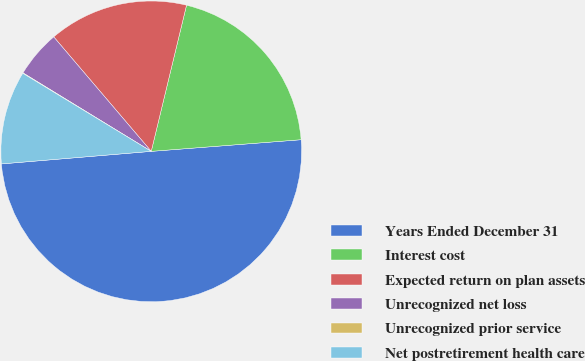Convert chart to OTSL. <chart><loc_0><loc_0><loc_500><loc_500><pie_chart><fcel>Years Ended December 31<fcel>Interest cost<fcel>Expected return on plan assets<fcel>Unrecognized net loss<fcel>Unrecognized prior service<fcel>Net postretirement health care<nl><fcel>49.9%<fcel>19.99%<fcel>15.0%<fcel>5.03%<fcel>0.05%<fcel>10.02%<nl></chart> 